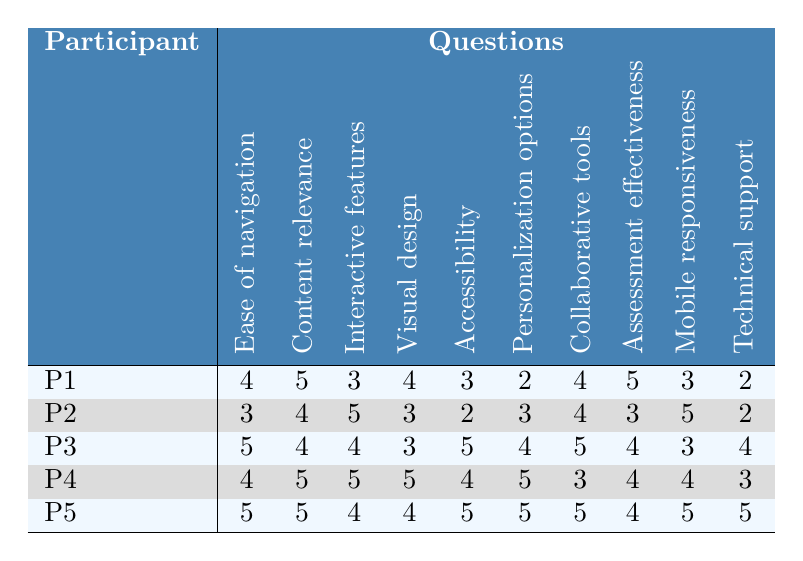What is the highest score given for "Ease of navigation"? The highest score across all participants for "Ease of navigation" is found by looking at the corresponding values in that column. The scores are 4, 3, 5, 4, and 5; thus, the highest is 5.
Answer: 5 Who is the participant that rated "Content relevance" with the lowest score? The scores for "Content relevance" are 5, 4, 4, 5, and 5. The lowest score is 4, which was given by participants P2, P3, and P4.
Answer: P2, P3, P4 What is the average score for "Mobile responsiveness" across all participants? Adding the scores for "Mobile responsiveness" gives 3 + 5 + 3 + 4 + 5 = 20. There are 5 participants. To find the average, divide the total by the number of participants: 20/5 = 4.
Answer: 4 Which question received the highest average score across all participants? Calculate the average for each question: 4.2 for "Ease of navigation," 4.6 for "Content relevance," 4.2 for "Interactive features," 4.2 for "Visual design," 3.8 for "Accessibility," 3.0 for "Personalization options," 4.2 for "Collaborative tools," 3.8 for "Assessment effectiveness," 4.0 for "Mobile responsiveness," and 3.2 for "Technical support." The highest average score is 4.6 for "Content relevance."
Answer: Content relevance Did any participant score below 3 for "Technical support"? Checking the scores for "Technical support," we see they are 2, 2, 4, 3, and 5. Yes, participants P1 and P2 scored below 3.
Answer: Yes What is the difference between the highest and lowest scores for "Visual design"? The scores for "Visual design" are 4, 3, 3, 5, and 4. The highest score is 5 and the lowest is 3. The difference is 5 - 3 = 2.
Answer: 2 Which participant rated all questions above 4? Looking at each participant's scores, P3 scored 4 or above in all cases with scores: 5, 4, 4, 3, 5, 4, 5, 4, 3, 4. This participant did not meet the criteria. However, P5's lowest score is 4, meeting the criteria.
Answer: P5 How many participants rated "Personalization options" as a 2? Reviewing the scores for "Personalization options," we have values 2, 3, 4, 5, and 5. Only one participant, P1, rated it as a 2.
Answer: 1 For "Accessibility," what percentage of participants rated it as a score of 5? Only P3 and P5 rated "Accessibility" as 5, out of 5 participants. To calculate the percentage, (2/5)*100 = 40%.
Answer: 40% Did the majority of participants find "Interactive features" effective (score 4 or above)? The scores for "Interactive features" are 3, 5, 4, 5, and 4. Three participants rated it as 4 or above, and two scored below. Since 3 out of 5 is a majority, the answer is yes.
Answer: Yes What is the median score for "Assessment effectiveness"? The scores for "Assessment effectiveness" are 5, 3, 4, 4, and 4. Arranging these gives 3, 4, 4, 4, 5. The median is the middle value, which is 4.
Answer: 4 